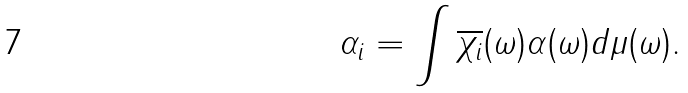<formula> <loc_0><loc_0><loc_500><loc_500>\alpha _ { i } = \int \overline { \chi _ { i } } ( \omega ) \alpha ( \omega ) d \mu ( \omega ) .</formula> 